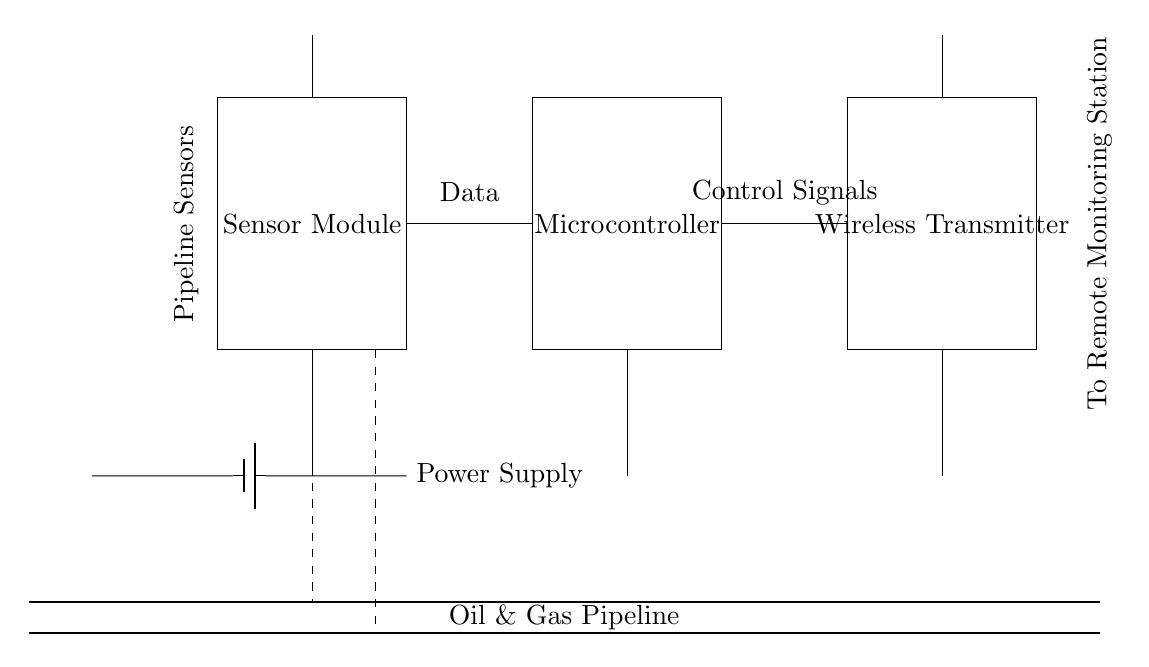What is the main purpose of the sensor module? The sensor module is responsible for monitoring the integrity of the oil and gas pipeline. The diagram shows that it is connected to the pipeline and provides data to the microcontroller, indicating its primary function as a sensor.
Answer: Monitoring pipeline integrity What does the wireless transmitter send to the monitoring station? The circuit diagram indicates that the wireless transmitter sends control signals to the remote monitoring station. This is shown by the connection labeled "To Remote Monitoring Station" directly above the transmitter.
Answer: Control signals How many major components are in the circuit? There are four major components shown in the diagram: the sensor module, microcontroller, wireless transmitter, and power supply. Counting these distinct rectangles gives the total number.
Answer: Four What type of communication does this circuit utilize? The circuit utilizes wireless communication, as indicated by the presence of antennas connected to both the sensor module and the wireless transmitter. This shows the data transfer occurs without physical cables.
Answer: Wireless What is the voltage source for the circuit? The circuit is powered by a battery, as indicated by the "Power Supply" label next to the symbol for the battery. This confirms that the circuit receives its voltage from this battery source.
Answer: Battery How are the sensors connected to the pipeline? The sensors are connected to the pipeline using dashed lines, which indicate a non-electrical connection to the pipeline. This visually represents their placement along the pipeline for monitoring purposes.
Answer: Dashed lines What indicates the data flow direction in the circuit? The arrows and labels in the diagram indicate the data flow between components. The connections labeled "Data" from the sensor module to the microcontroller, and "Control Signals" from the microcontroller to the wireless transmitter illustrate the direction of the data flow.
Answer: Arrows and labels 